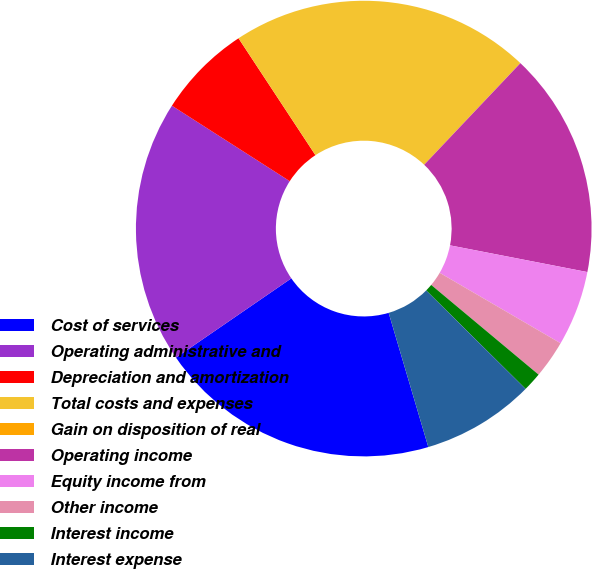Convert chart. <chart><loc_0><loc_0><loc_500><loc_500><pie_chart><fcel>Cost of services<fcel>Operating administrative and<fcel>Depreciation and amortization<fcel>Total costs and expenses<fcel>Gain on disposition of real<fcel>Operating income<fcel>Equity income from<fcel>Other income<fcel>Interest income<fcel>Interest expense<nl><fcel>19.99%<fcel>18.65%<fcel>6.67%<fcel>21.32%<fcel>0.01%<fcel>15.99%<fcel>5.34%<fcel>2.68%<fcel>1.35%<fcel>8.0%<nl></chart> 